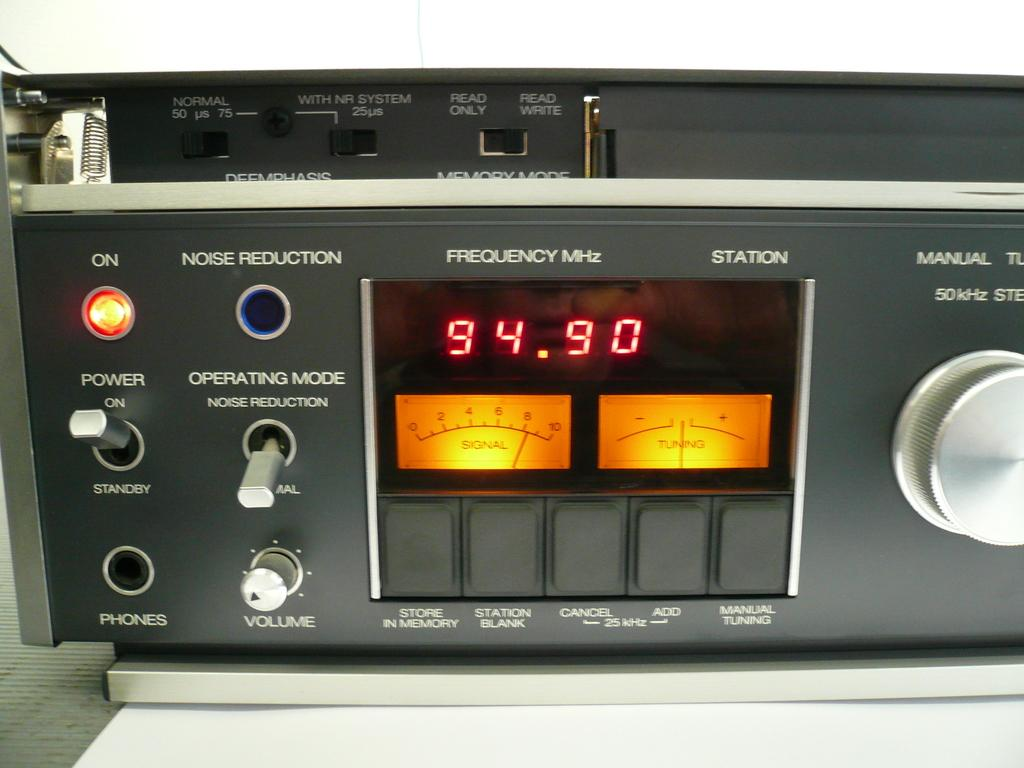<image>
Summarize the visual content of the image. A grey digital scanner displaying the image of 94.50. 